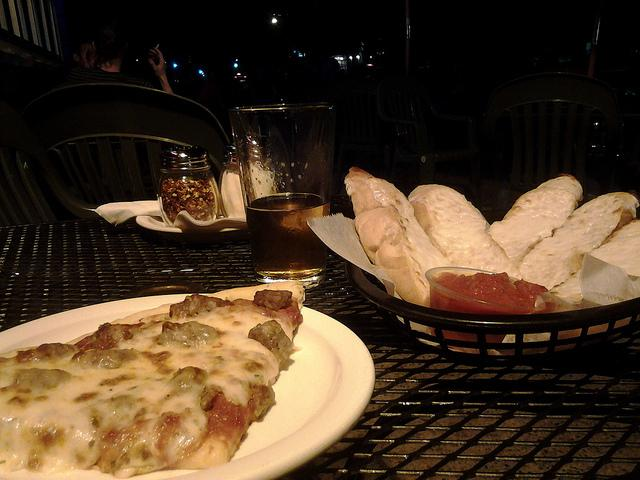What is the bread in?

Choices:
A) cats mouth
B) basket
C) box
D) dogs paw basket 